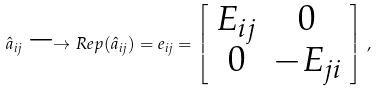<formula> <loc_0><loc_0><loc_500><loc_500>\hat { a } _ { i j } \longrightarrow R e p ( \hat { a } _ { i j } ) = e _ { i j } = \left [ \begin{array} { c c } E _ { i j } & 0 \\ 0 & - E _ { j i } \end{array} \right ] \, ,</formula> 